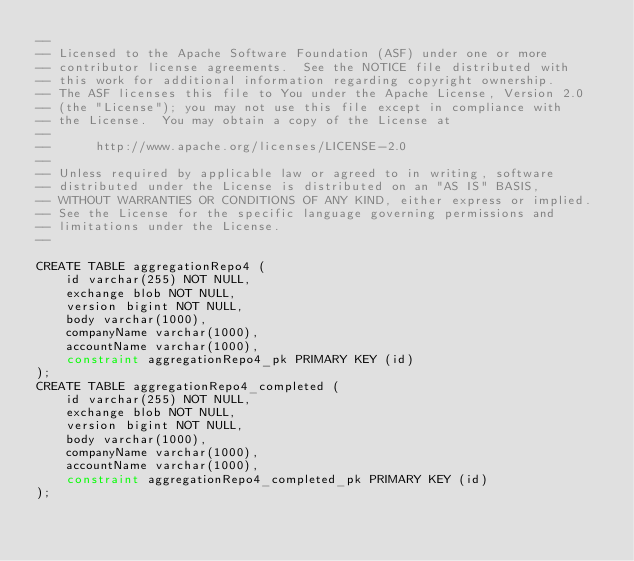Convert code to text. <code><loc_0><loc_0><loc_500><loc_500><_SQL_>--
-- Licensed to the Apache Software Foundation (ASF) under one or more
-- contributor license agreements.  See the NOTICE file distributed with
-- this work for additional information regarding copyright ownership.
-- The ASF licenses this file to You under the Apache License, Version 2.0
-- (the "License"); you may not use this file except in compliance with
-- the License.  You may obtain a copy of the License at
--
--      http://www.apache.org/licenses/LICENSE-2.0
--
-- Unless required by applicable law or agreed to in writing, software
-- distributed under the License is distributed on an "AS IS" BASIS,
-- WITHOUT WARRANTIES OR CONDITIONS OF ANY KIND, either express or implied.
-- See the License for the specific language governing permissions and
-- limitations under the License.
--

CREATE TABLE aggregationRepo4 (
    id varchar(255) NOT NULL,
    exchange blob NOT NULL,
    version bigint NOT NULL,
    body varchar(1000),
    companyName varchar(1000),
    accountName varchar(1000),
    constraint aggregationRepo4_pk PRIMARY KEY (id)
);
CREATE TABLE aggregationRepo4_completed (
    id varchar(255) NOT NULL,
    exchange blob NOT NULL,
    version bigint NOT NULL,
    body varchar(1000),
    companyName varchar(1000),
    accountName varchar(1000),
    constraint aggregationRepo4_completed_pk PRIMARY KEY (id)
);</code> 